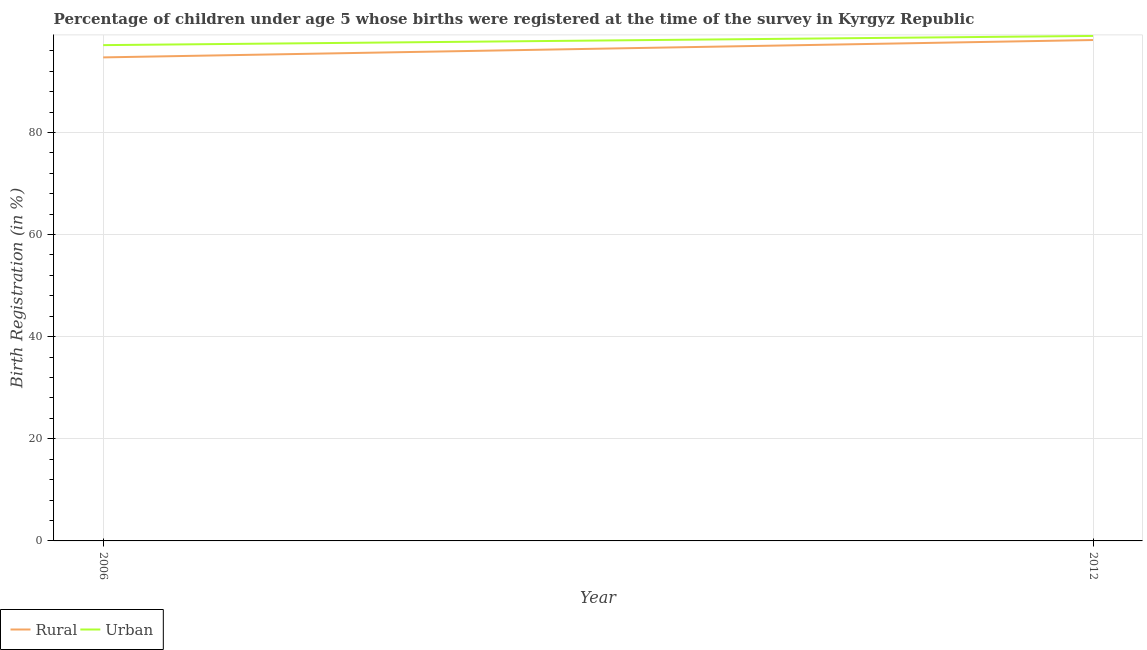Does the line corresponding to rural birth registration intersect with the line corresponding to urban birth registration?
Make the answer very short. No. Is the number of lines equal to the number of legend labels?
Make the answer very short. Yes. What is the rural birth registration in 2012?
Ensure brevity in your answer.  98.1. Across all years, what is the maximum urban birth registration?
Your answer should be compact. 98.9. Across all years, what is the minimum rural birth registration?
Offer a terse response. 94.7. In which year was the urban birth registration minimum?
Give a very brief answer. 2006. What is the total rural birth registration in the graph?
Offer a very short reply. 192.8. What is the difference between the urban birth registration in 2006 and that in 2012?
Offer a terse response. -1.8. What is the difference between the rural birth registration in 2012 and the urban birth registration in 2006?
Ensure brevity in your answer.  1. What is the average rural birth registration per year?
Offer a terse response. 96.4. In the year 2006, what is the difference between the rural birth registration and urban birth registration?
Make the answer very short. -2.4. In how many years, is the rural birth registration greater than 4 %?
Provide a succinct answer. 2. What is the ratio of the urban birth registration in 2006 to that in 2012?
Make the answer very short. 0.98. In how many years, is the urban birth registration greater than the average urban birth registration taken over all years?
Make the answer very short. 1. Is the rural birth registration strictly less than the urban birth registration over the years?
Your response must be concise. Yes. How many lines are there?
Your response must be concise. 2. How many years are there in the graph?
Keep it short and to the point. 2. Are the values on the major ticks of Y-axis written in scientific E-notation?
Provide a succinct answer. No. Does the graph contain any zero values?
Give a very brief answer. No. Where does the legend appear in the graph?
Provide a succinct answer. Bottom left. How many legend labels are there?
Your answer should be compact. 2. What is the title of the graph?
Give a very brief answer. Percentage of children under age 5 whose births were registered at the time of the survey in Kyrgyz Republic. What is the label or title of the X-axis?
Keep it short and to the point. Year. What is the label or title of the Y-axis?
Your answer should be very brief. Birth Registration (in %). What is the Birth Registration (in %) of Rural in 2006?
Your answer should be compact. 94.7. What is the Birth Registration (in %) of Urban in 2006?
Ensure brevity in your answer.  97.1. What is the Birth Registration (in %) of Rural in 2012?
Provide a succinct answer. 98.1. What is the Birth Registration (in %) in Urban in 2012?
Your response must be concise. 98.9. Across all years, what is the maximum Birth Registration (in %) in Rural?
Your answer should be very brief. 98.1. Across all years, what is the maximum Birth Registration (in %) in Urban?
Offer a terse response. 98.9. Across all years, what is the minimum Birth Registration (in %) of Rural?
Offer a very short reply. 94.7. Across all years, what is the minimum Birth Registration (in %) of Urban?
Keep it short and to the point. 97.1. What is the total Birth Registration (in %) of Rural in the graph?
Offer a terse response. 192.8. What is the total Birth Registration (in %) in Urban in the graph?
Offer a very short reply. 196. What is the average Birth Registration (in %) in Rural per year?
Provide a succinct answer. 96.4. What is the average Birth Registration (in %) of Urban per year?
Keep it short and to the point. 98. In the year 2012, what is the difference between the Birth Registration (in %) in Rural and Birth Registration (in %) in Urban?
Your answer should be compact. -0.8. What is the ratio of the Birth Registration (in %) of Rural in 2006 to that in 2012?
Provide a succinct answer. 0.97. What is the ratio of the Birth Registration (in %) in Urban in 2006 to that in 2012?
Offer a terse response. 0.98. What is the difference between the highest and the second highest Birth Registration (in %) of Rural?
Provide a short and direct response. 3.4. What is the difference between the highest and the lowest Birth Registration (in %) in Rural?
Provide a succinct answer. 3.4. 